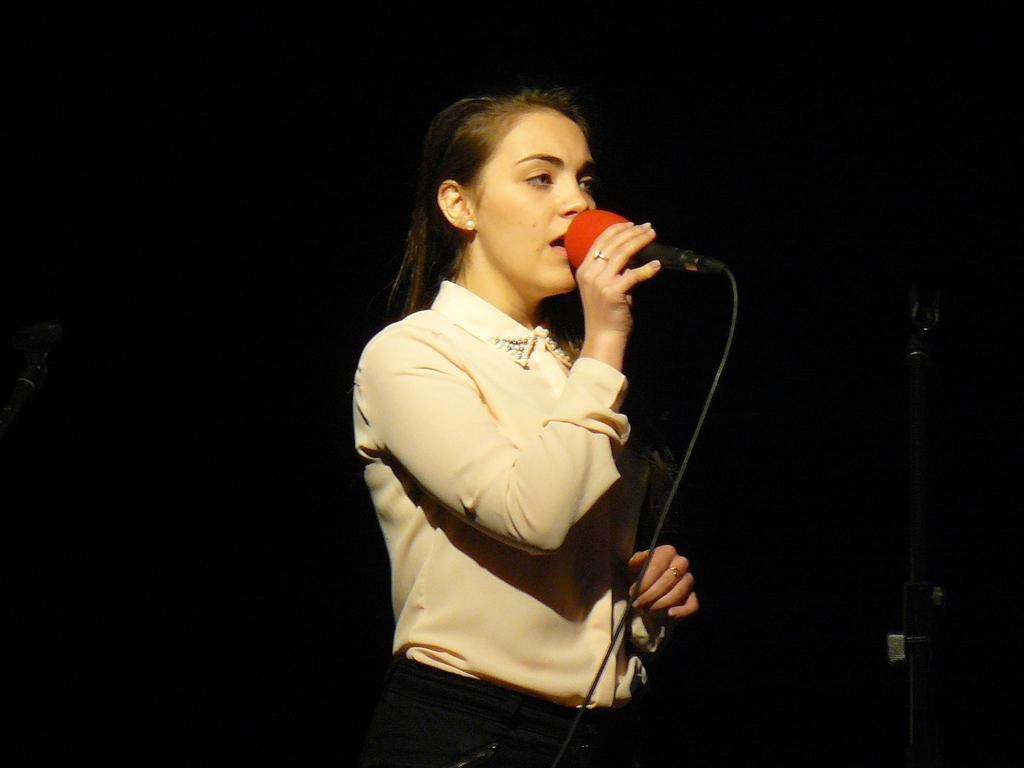Could you give a brief overview of what you see in this image? In the picture I can see a person wearing a shirt is standing here and holding a mic in her hand and the background of the image is dark 